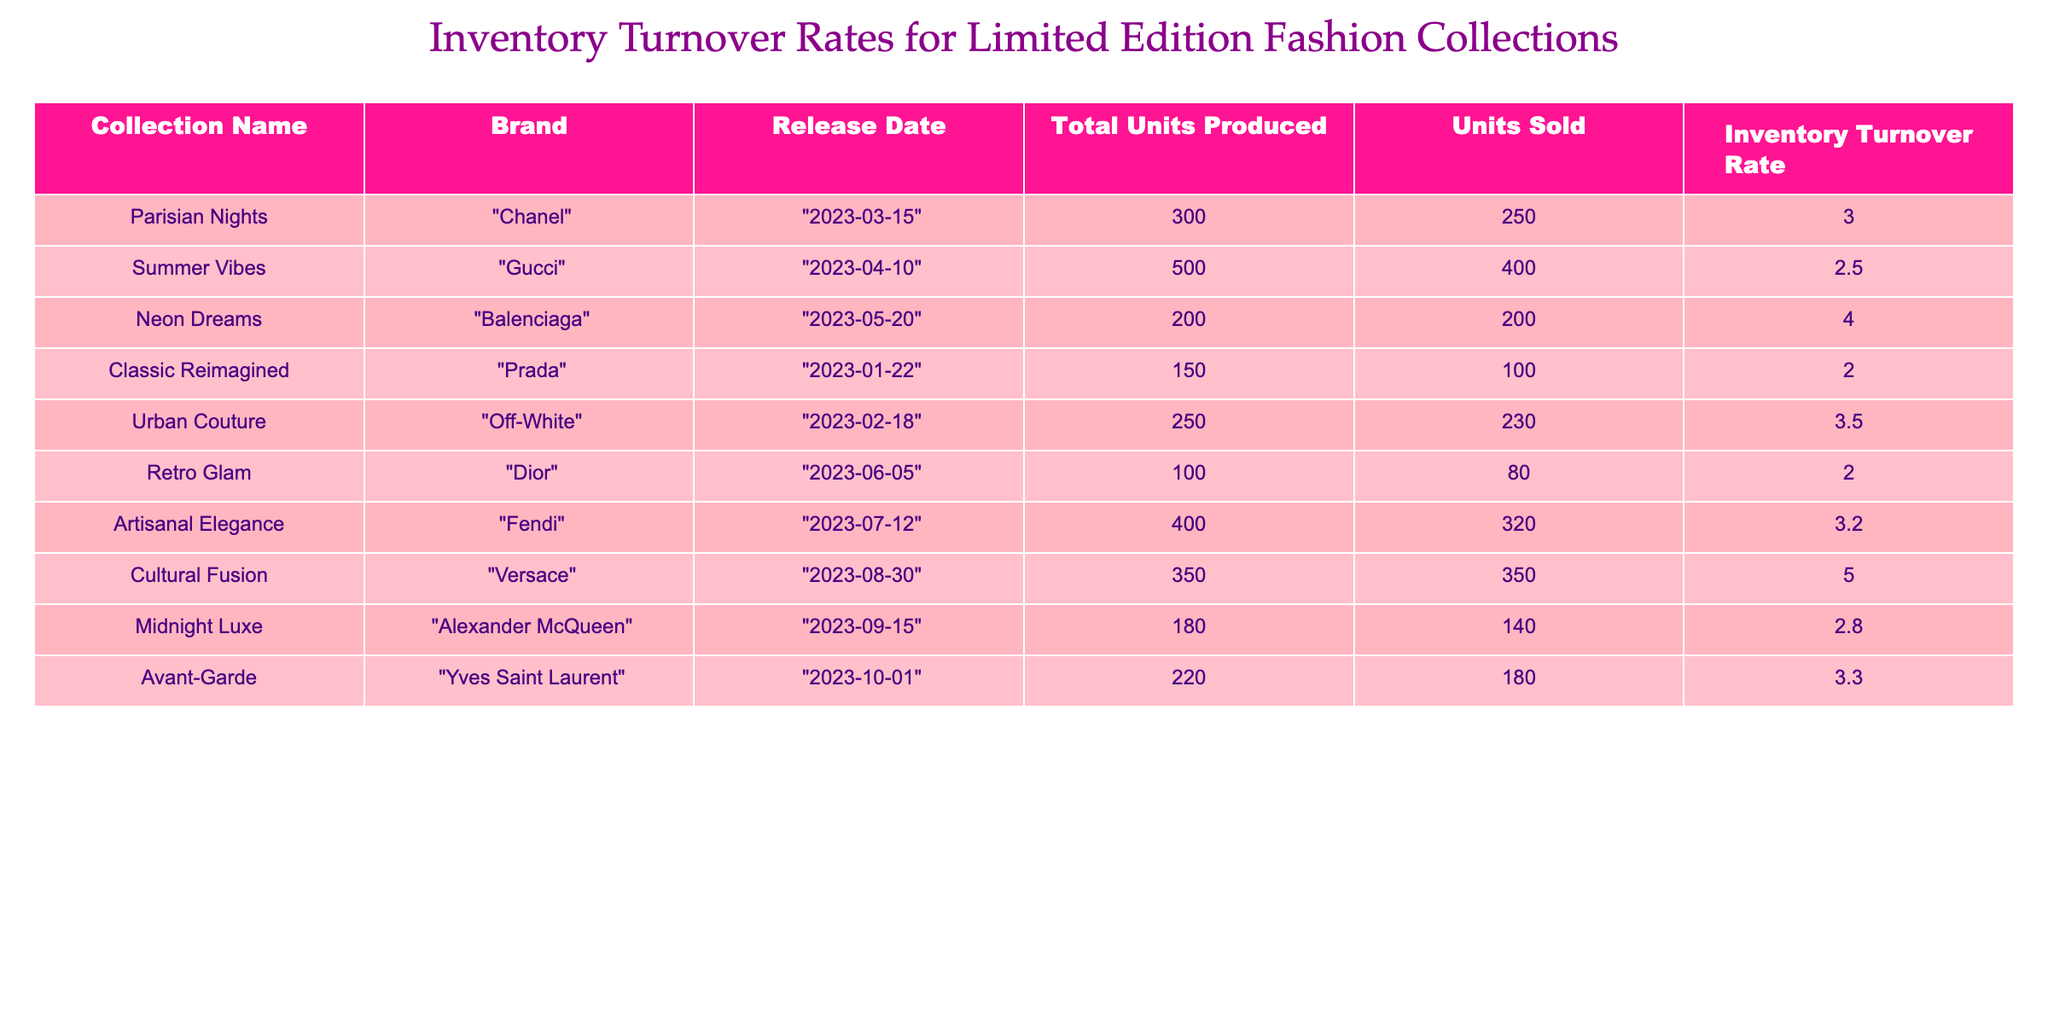What is the inventory turnover rate for the "Neon Dreams" collection? The table shows the inventory turnover rate for each collection. For "Neon Dreams", the corresponding value in the "Inventory Turnover Rate" column is 4.0.
Answer: 4.0 Which collection has the highest number of units sold? Comparing the "Units Sold" column for each collection, "Cultural Fusion" and "Neon Dreams" both have 350 units sold, but "Cultural Fusion" has produced 350 total units, leading to a higher turnover rate. However, since the question asks for the highest number of units, the answer is 350.
Answer: 350 What is the average inventory turnover rate for all collections? The total inventory turnover rates are 3.0 + 2.5 + 4.0 + 2.0 + 3.5 + 2.0 + 3.2 + 5.0 + 2.8 + 3.3 = 28.3. There are 10 collections, so the average is 28.3 / 10 = 2.83.
Answer: 2.83 Did "Urban Couture" sell more units than "Retro Glam"? Checking the "Units Sold" for both collections, "Urban Couture" has 230 units sold and "Retro Glam" has 80 units sold. Therefore, Urban Couture sold more units.
Answer: Yes Is the inventory turnover rate for "Classic Reimagined" greater than 2? From the table, the inventory turnover rate for "Classic Reimagined" is 2.0. Since 2.0 is not greater than 2, the answer is no.
Answer: No Which brand has the lowest inventory turnover rate? Reviewing the inventory turnover rates, "Classic Reimagined" and "Retro Glam" both have 2.0, but "Classic Reimagined" is listed first in the table. So it is the lowest in the entries provided.
Answer: Classic Reimagined What is the total number of units produced across all collections? To find the total units produced, I will sum all entries in the "Total Units Produced" column: 300 + 500 + 200 + 150 + 250 + 100 + 400 + 350 + 180 + 220 = 2650.
Answer: 2650 How many collections have an inventory turnover rate greater than 3? From the table, the collections with rates greater than 3 are "Parisian Nights" (3.0), "Neon Dreams" (4.0), "Urban Couture" (3.5), "Artisanal Elegance" (3.2), "Avant-Garde" (3.3) and "Cultural Fusion" (5.0). Therefore, 5 collections satisfy this condition.
Answer: 5 What is the difference in units sold between "Summer Vibes" and "Midnight Luxe"? The "Units Sold" for "Summer Vibes" is 400 and for "Midnight Luxe" is 140. The difference is 400 - 140 = 260 units.
Answer: 260 